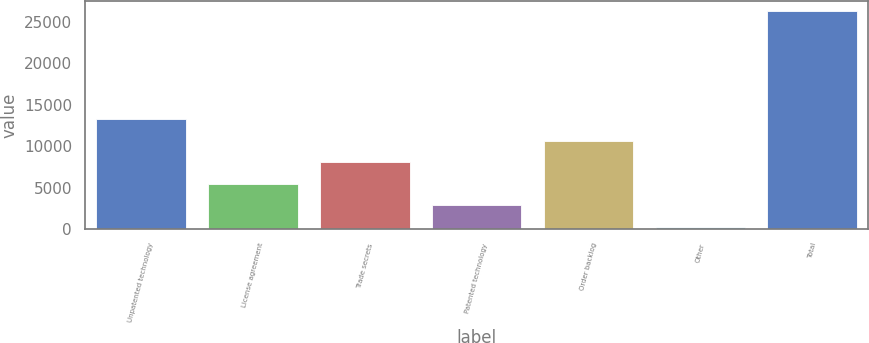Convert chart to OTSL. <chart><loc_0><loc_0><loc_500><loc_500><bar_chart><fcel>Unpatented technology<fcel>License agreement<fcel>Trade secrets<fcel>Patented technology<fcel>Order backlog<fcel>Other<fcel>Total<nl><fcel>13264.5<fcel>5476.8<fcel>8072.7<fcel>2880.9<fcel>10668.6<fcel>285<fcel>26244<nl></chart> 